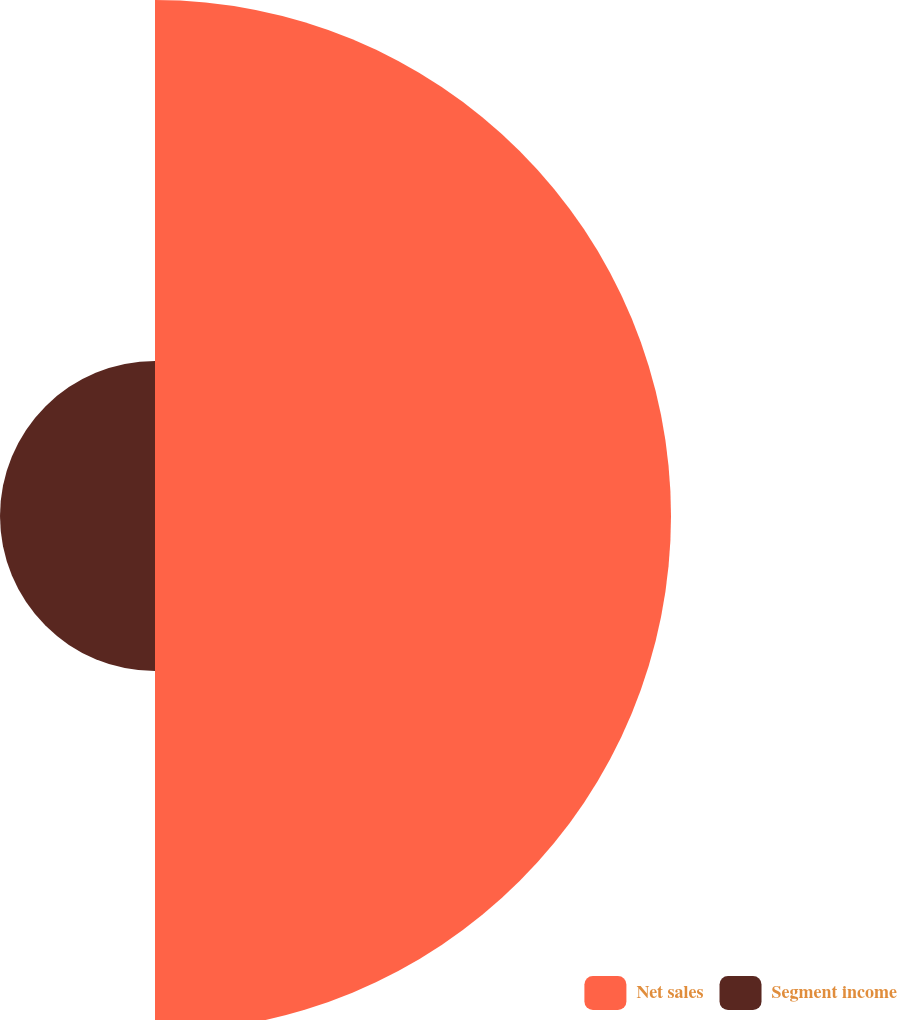Convert chart. <chart><loc_0><loc_0><loc_500><loc_500><pie_chart><fcel>Net sales<fcel>Segment income<nl><fcel>76.9%<fcel>23.1%<nl></chart> 